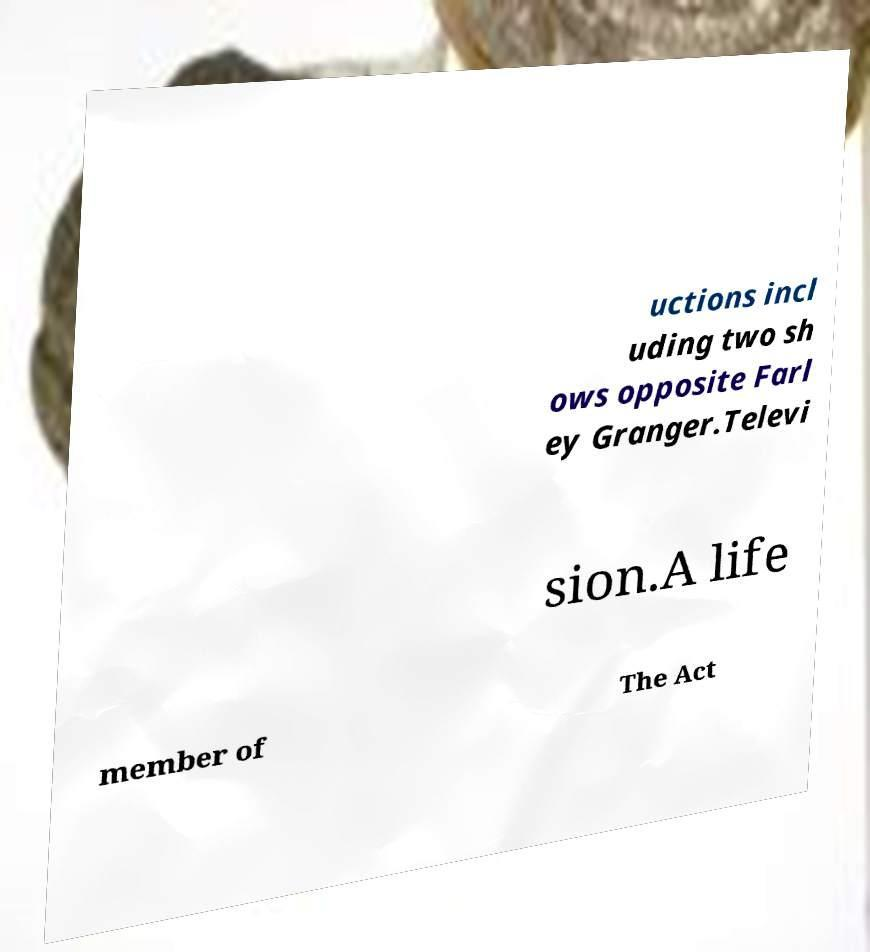Please identify and transcribe the text found in this image. uctions incl uding two sh ows opposite Farl ey Granger.Televi sion.A life member of The Act 